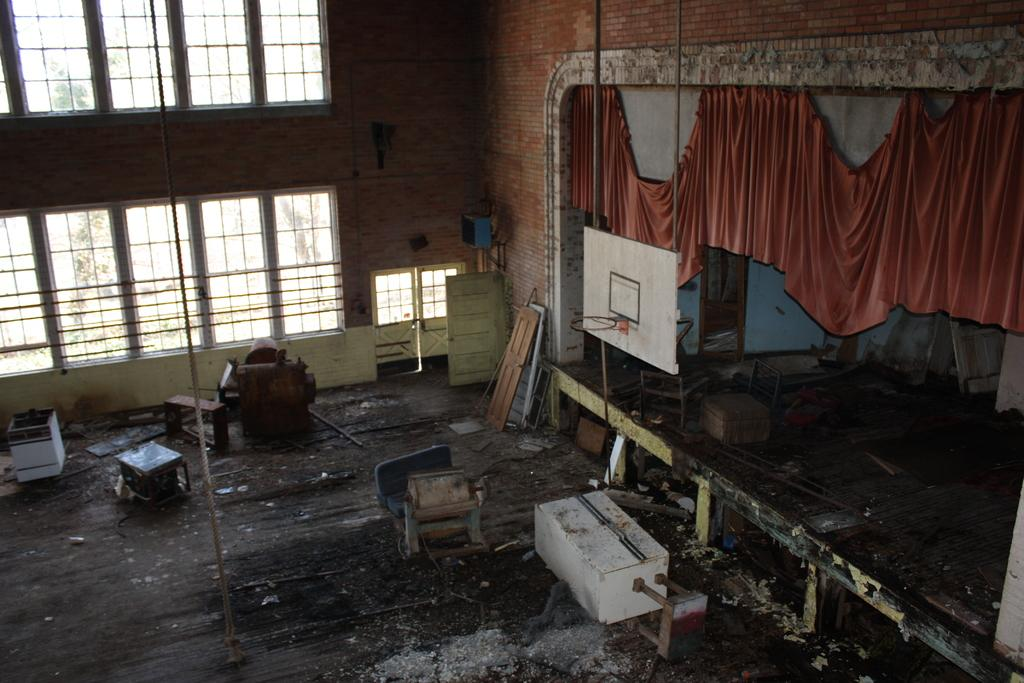What can be seen through the windows in the image? The details of what can be seen through the windows are not provided in the facts. What is located on the right side of the image? There is a curtain on the right side of the image. What type of verse is being recited in the lunchroom in the image? There is no mention of a lunchroom or any verse being recited in the image. Can you see a toad sitting on the curtain in the image? There is no toad present in the image. 